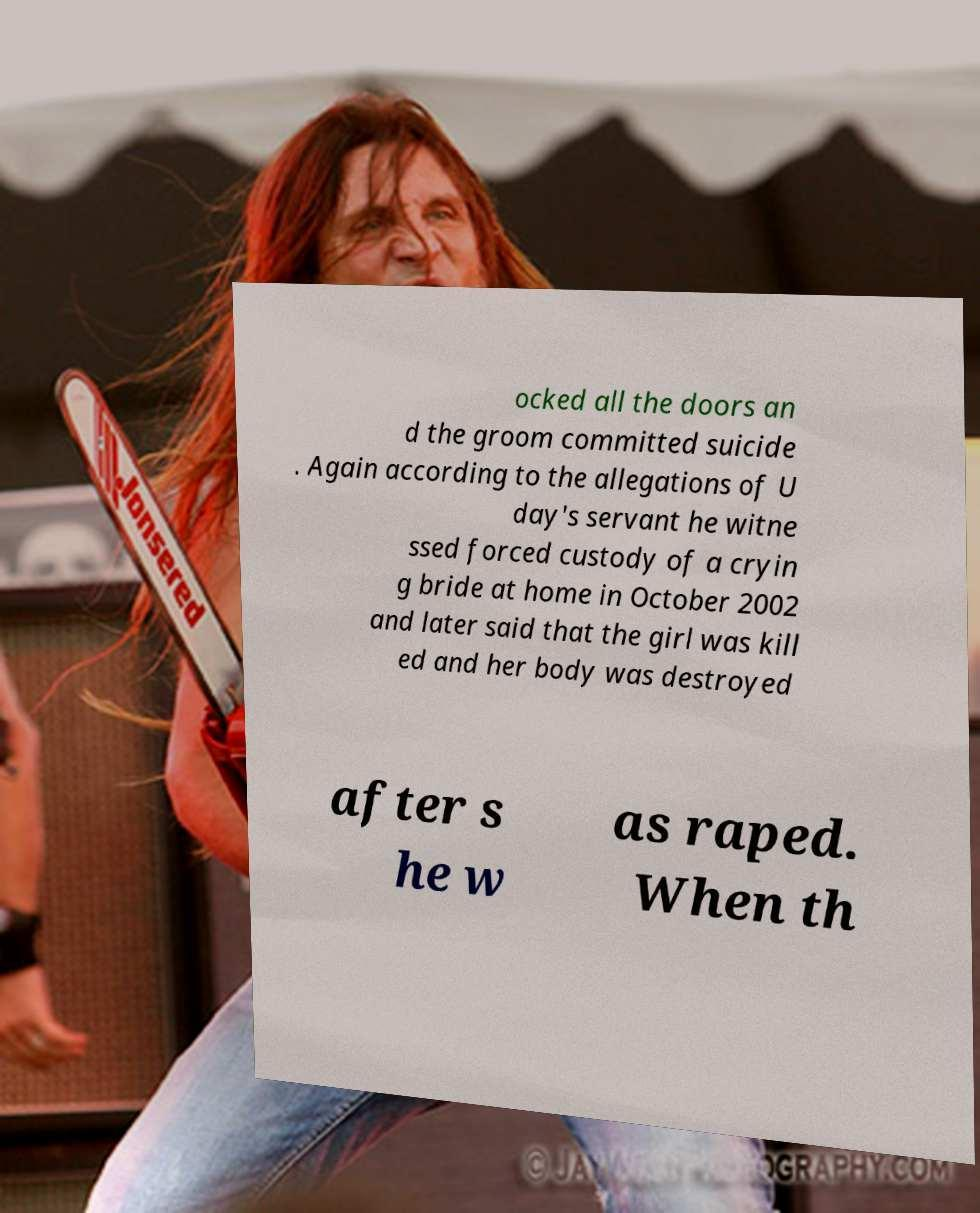Could you extract and type out the text from this image? ocked all the doors an d the groom committed suicide . Again according to the allegations of U day's servant he witne ssed forced custody of a cryin g bride at home in October 2002 and later said that the girl was kill ed and her body was destroyed after s he w as raped. When th 